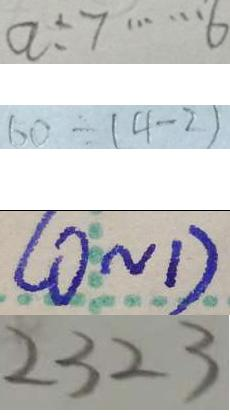<formula> <loc_0><loc_0><loc_500><loc_500>a \div 7 \cdots 6 
 6 0 \div ( 4 - 2 ) 
 ( 0 \sim 1 ) 
 2 3 2 3</formula> 